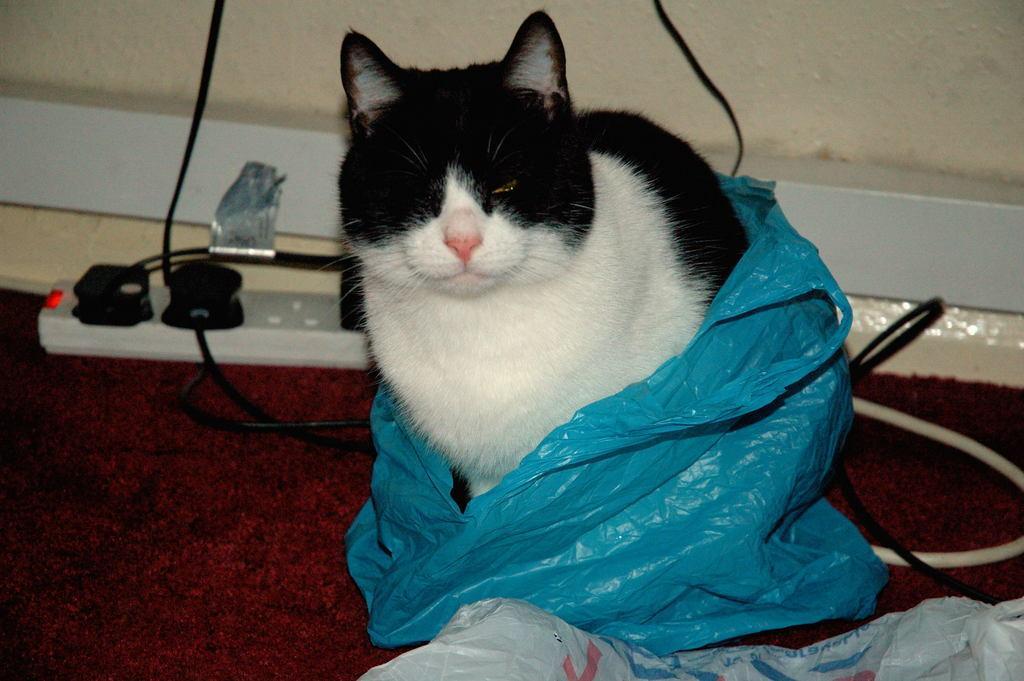Can you describe this image briefly? In this image I can see the cat in black and white color and the blue color cover to it. I can see the extension-board, wires, wall and few objects. 